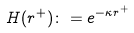<formula> <loc_0><loc_0><loc_500><loc_500>H ( r ^ { + } ) \colon = e ^ { - \kappa r ^ { + } }</formula> 